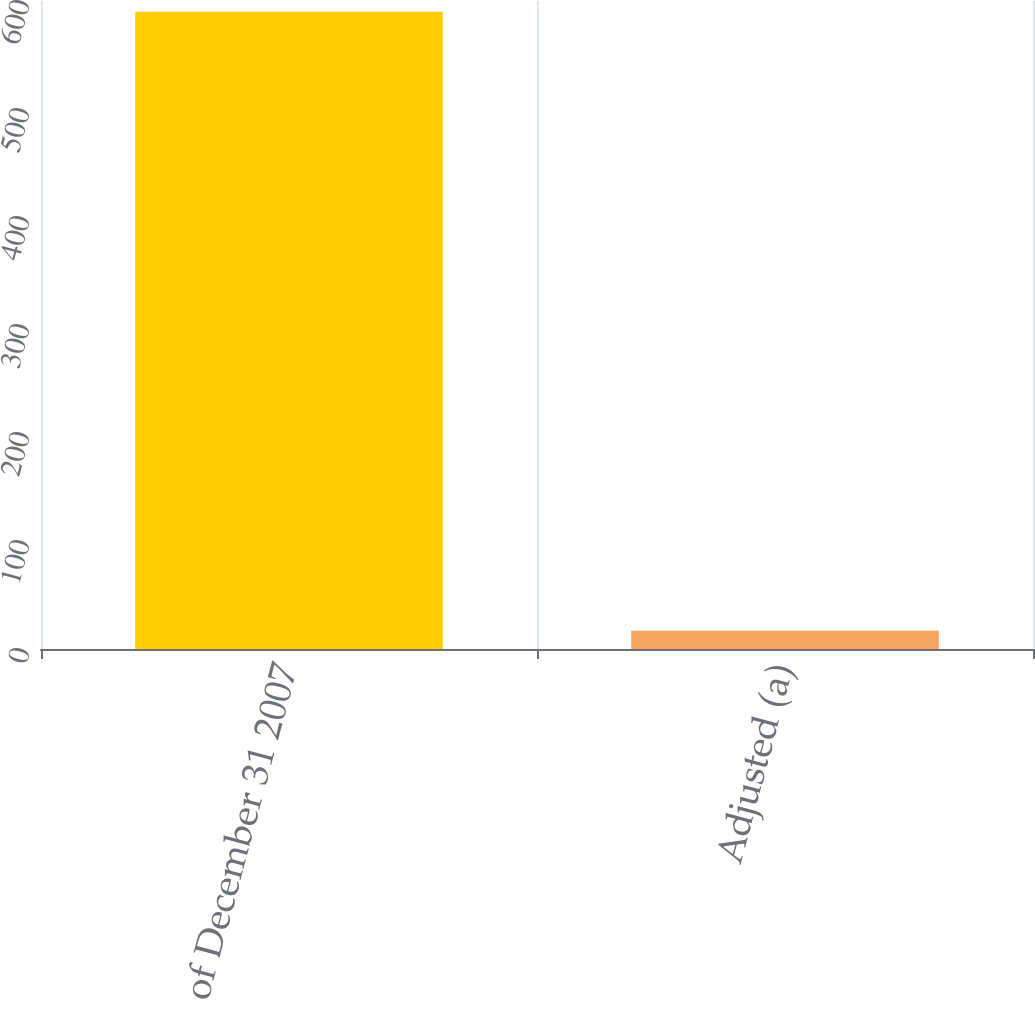<chart> <loc_0><loc_0><loc_500><loc_500><bar_chart><fcel>Balance as of December 31 2007<fcel>Adjusted (a)<nl><fcel>590<fcel>17<nl></chart> 